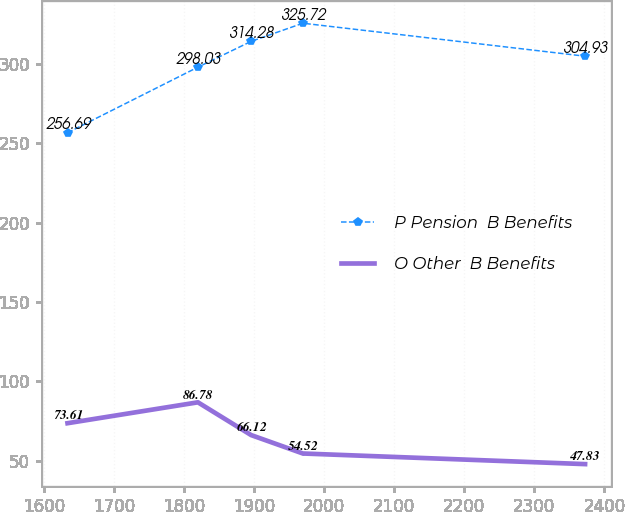Convert chart. <chart><loc_0><loc_0><loc_500><loc_500><line_chart><ecel><fcel>P Pension  B Benefits<fcel>O Other  B Benefits<nl><fcel>1633.56<fcel>256.69<fcel>73.61<nl><fcel>1819.72<fcel>298.03<fcel>86.78<nl><fcel>1895.72<fcel>314.28<fcel>66.12<nl><fcel>1969.61<fcel>325.72<fcel>54.52<nl><fcel>2372.45<fcel>304.93<fcel>47.83<nl></chart> 